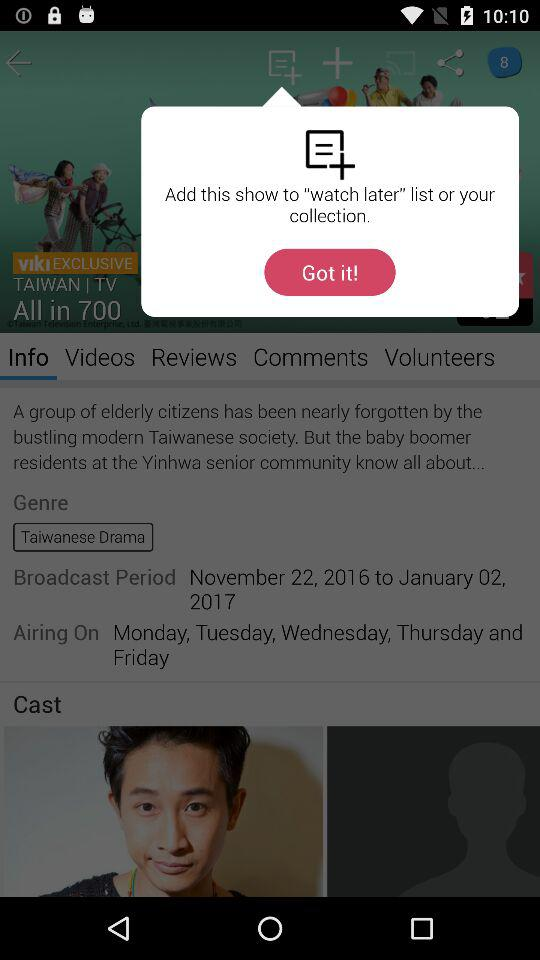What is the genre of the drama? The genre is "Taiwanese Drama". 